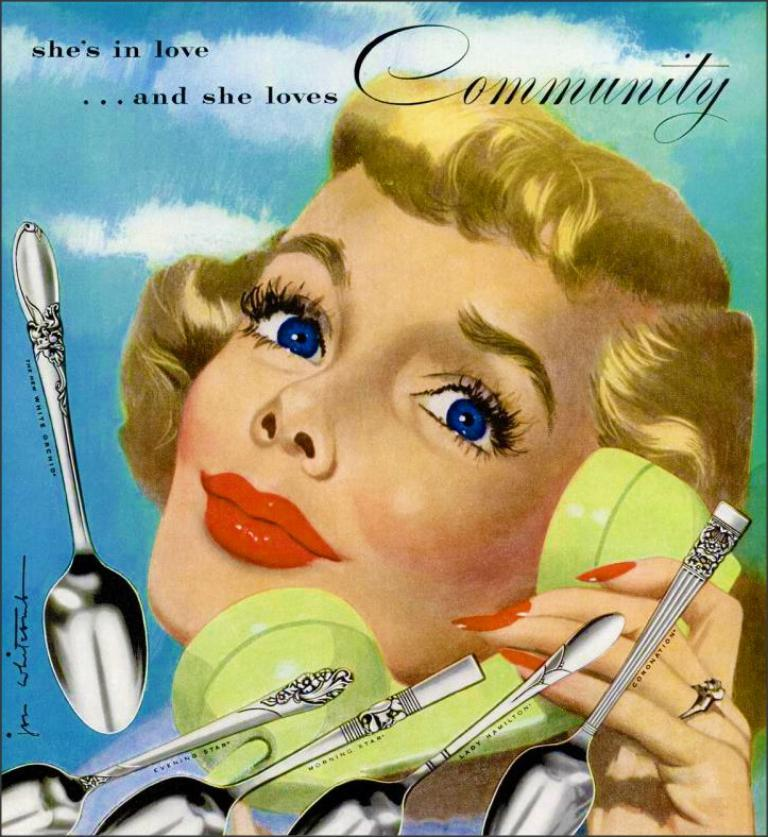What type of artwork is depicted in the image? The image is a painting. Who or what is the main subject of the painting? There is a woman in the image. What is the woman holding in the painting? The woman is holding a phone. What other objects can be seen in the painting? There are spoons in the image. What can be seen in the background of the painting? The sky is visible in the background of the image. Is there any text present in the painting? Yes, there is text on the image. Can you see a branch growing from the woman's phone in the image? No, there is no branch growing from the woman's phone in the image. Is there a snail crawling on the spoons in the image? No, there is no snail present in the image. 